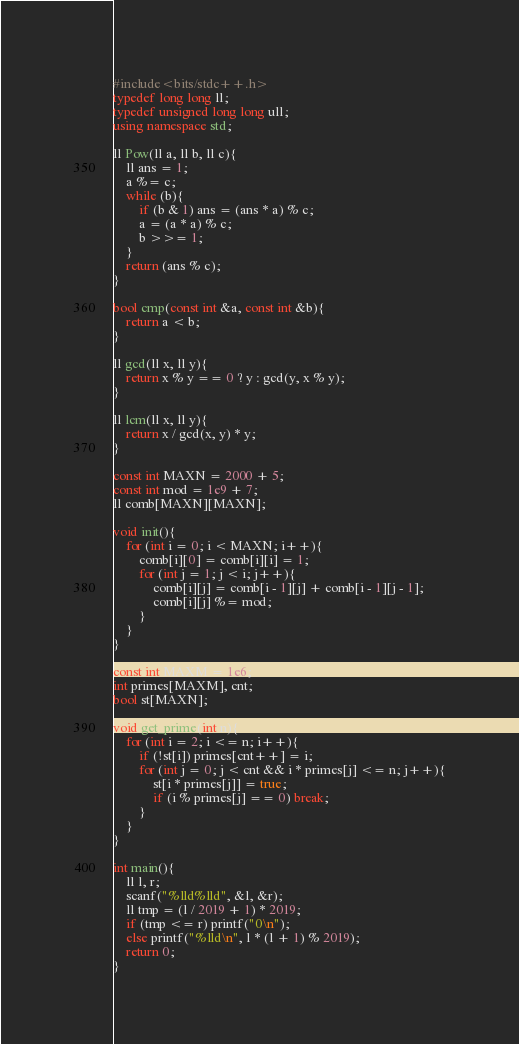<code> <loc_0><loc_0><loc_500><loc_500><_C++_>#include<bits/stdc++.h>
typedef long long ll;
typedef unsigned long long ull;
using namespace std;

ll Pow(ll a, ll b, ll c){
    ll ans = 1;
    a %= c;
    while (b){
        if (b & 1) ans = (ans * a) % c;
        a = (a * a) % c;
        b >>= 1;
    }
    return (ans % c);
}

bool cmp(const int &a, const int &b){
    return a < b;
}

ll gcd(ll x, ll y){
    return x % y == 0 ? y : gcd(y, x % y);
}

ll lcm(ll x, ll y){
    return x / gcd(x, y) * y;
}

const int MAXN = 2000 + 5;
const int mod = 1e9 + 7;
ll comb[MAXN][MAXN];

void init(){
	for (int i = 0; i < MAXN; i++){
		comb[i][0] = comb[i][i] = 1;
		for (int j = 1; j < i; j++){
			comb[i][j] = comb[i - 1][j] + comb[i - 1][j - 1];
			comb[i][j] %= mod;
		}
	}
}

const int MAXM = 1e6;
int primes[MAXM], cnt;
bool st[MAXN];

void get_prime(int n){
	for (int i = 2; i <= n; i++){
		if (!st[i]) primes[cnt++] = i;
		for (int j = 0; j < cnt && i * primes[j] <= n; j++){
			st[i * primes[j]] = true;
			if (i % primes[j] == 0) break;
		}
	}
}

int main(){
    ll l, r;
    scanf("%lld%lld", &l, &r);
    ll tmp = (l / 2019 + 1) * 2019;
    if (tmp <= r) printf("0\n");
    else printf("%lld\n", l * (l + 1) % 2019);
    return 0;
}
</code> 